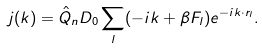<formula> <loc_0><loc_0><loc_500><loc_500>j ( k ) = \hat { Q } _ { n } D _ { 0 } \sum _ { l } ( - i k + \beta F _ { l } ) e ^ { - i k \cdot r _ { l } } .</formula> 